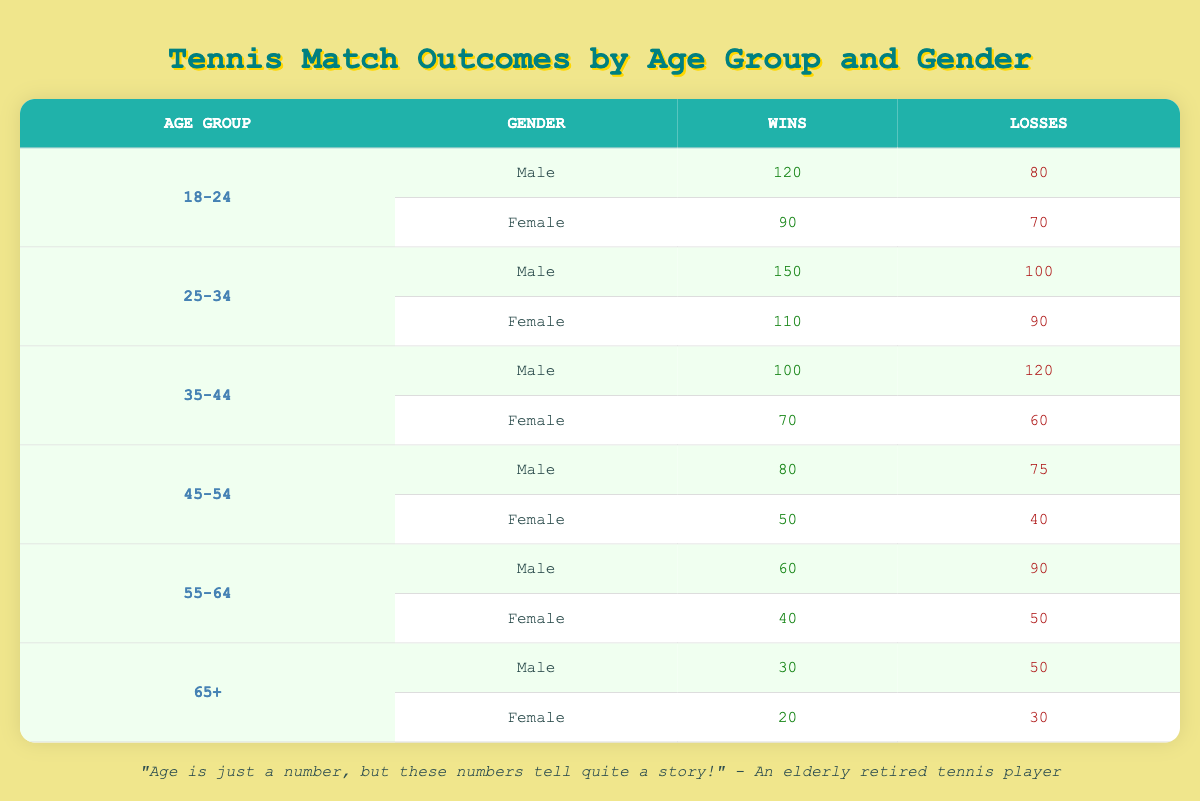What is the total number of wins for male players aged 35-44? In the table, for the age group 35-44, the male players have 100 wins.
Answer: 100 What is the total number of losses for female players in the age group 18-24? For the age group 18-24, the female players have recorded 70 losses.
Answer: 70 Which age group has the highest number of total wins for male players, and how many wins did they achieve? The age group 25-34 has the highest number of wins at 150 for male players.
Answer: 25-34, 150 Is the statement "Female players aged 65 and older have more losses than male players in the same age group" true? For 65+, female players have 30 losses while male players have 50 losses, making the statement false.
Answer: No What is the average number of wins for players in the age group 45-54? The total wins for the 45-54 age group is (80 + 50) = 130. Dividing this by 2, the average is 65.
Answer: 65 How many more wins do male players have compared to female players in the age group 25-34? Male players aged 25-34 have 150 wins and female players have 110 wins. The difference is 150 - 110 = 40.
Answer: 40 What is the total number of matches played by female players aged 55-64? The total matches played is the sum of wins and losses, which is 40 + 50 = 90 matches.
Answer: 90 Which gender performed better in the 45-54 age group in terms of wins? In the 45-54 age group, male players have 80 wins compared to 50 wins for female players, which indicates that male players performed better.
Answer: Male What is the total number of matches played by male players across all age groups? The total matches for male players are calculated by summing all wins and losses: (120 + 150 + 100 + 80 + 60 + 30) + (80 + 100 + 120 + 75 + 90 + 50) = 510.
Answer: 510 